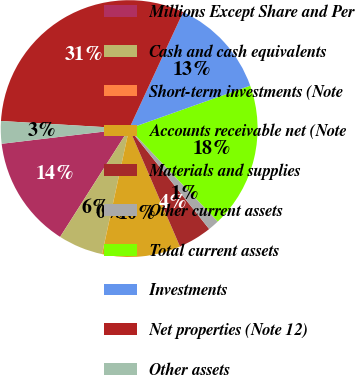<chart> <loc_0><loc_0><loc_500><loc_500><pie_chart><fcel>Millions Except Share and Per<fcel>Cash and cash equivalents<fcel>Short-term investments (Note<fcel>Accounts receivable net (Note<fcel>Materials and supplies<fcel>Other current assets<fcel>Total current assets<fcel>Investments<fcel>Net properties (Note 12)<fcel>Other assets<nl><fcel>14.08%<fcel>5.64%<fcel>0.01%<fcel>9.86%<fcel>4.23%<fcel>1.42%<fcel>18.3%<fcel>12.67%<fcel>30.96%<fcel>2.83%<nl></chart> 